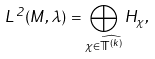<formula> <loc_0><loc_0><loc_500><loc_500>L ^ { 2 } ( M , \lambda ) = \bigoplus _ { \chi \in \widehat { { \mathbb { T } } ^ { ( k ) } } } H _ { \chi } ,</formula> 